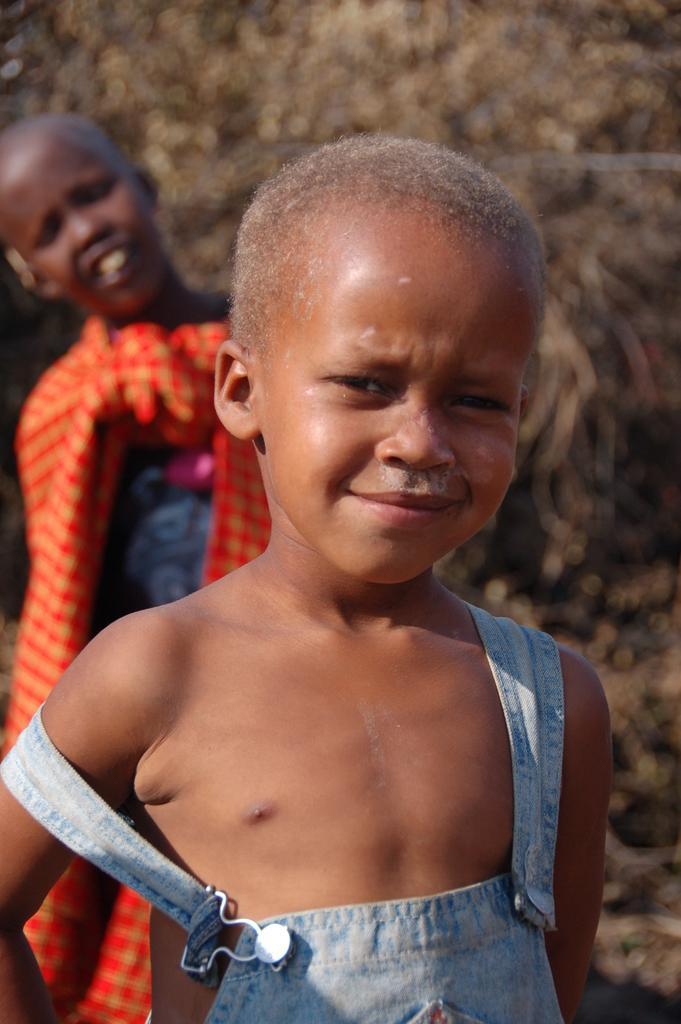How would you summarize this image in a sentence or two? In the picture we can see a small child standing with a bald head and behind we can see another person standing. 